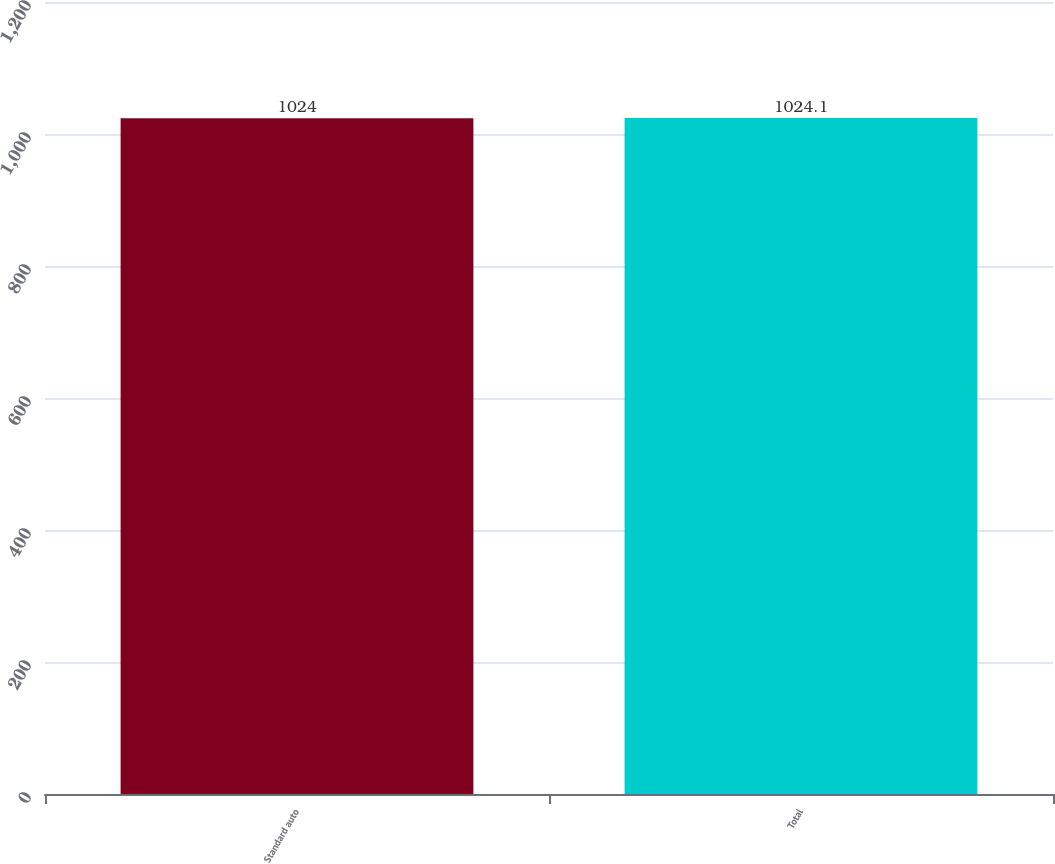<chart> <loc_0><loc_0><loc_500><loc_500><bar_chart><fcel>Standard auto<fcel>Total<nl><fcel>1024<fcel>1024.1<nl></chart> 